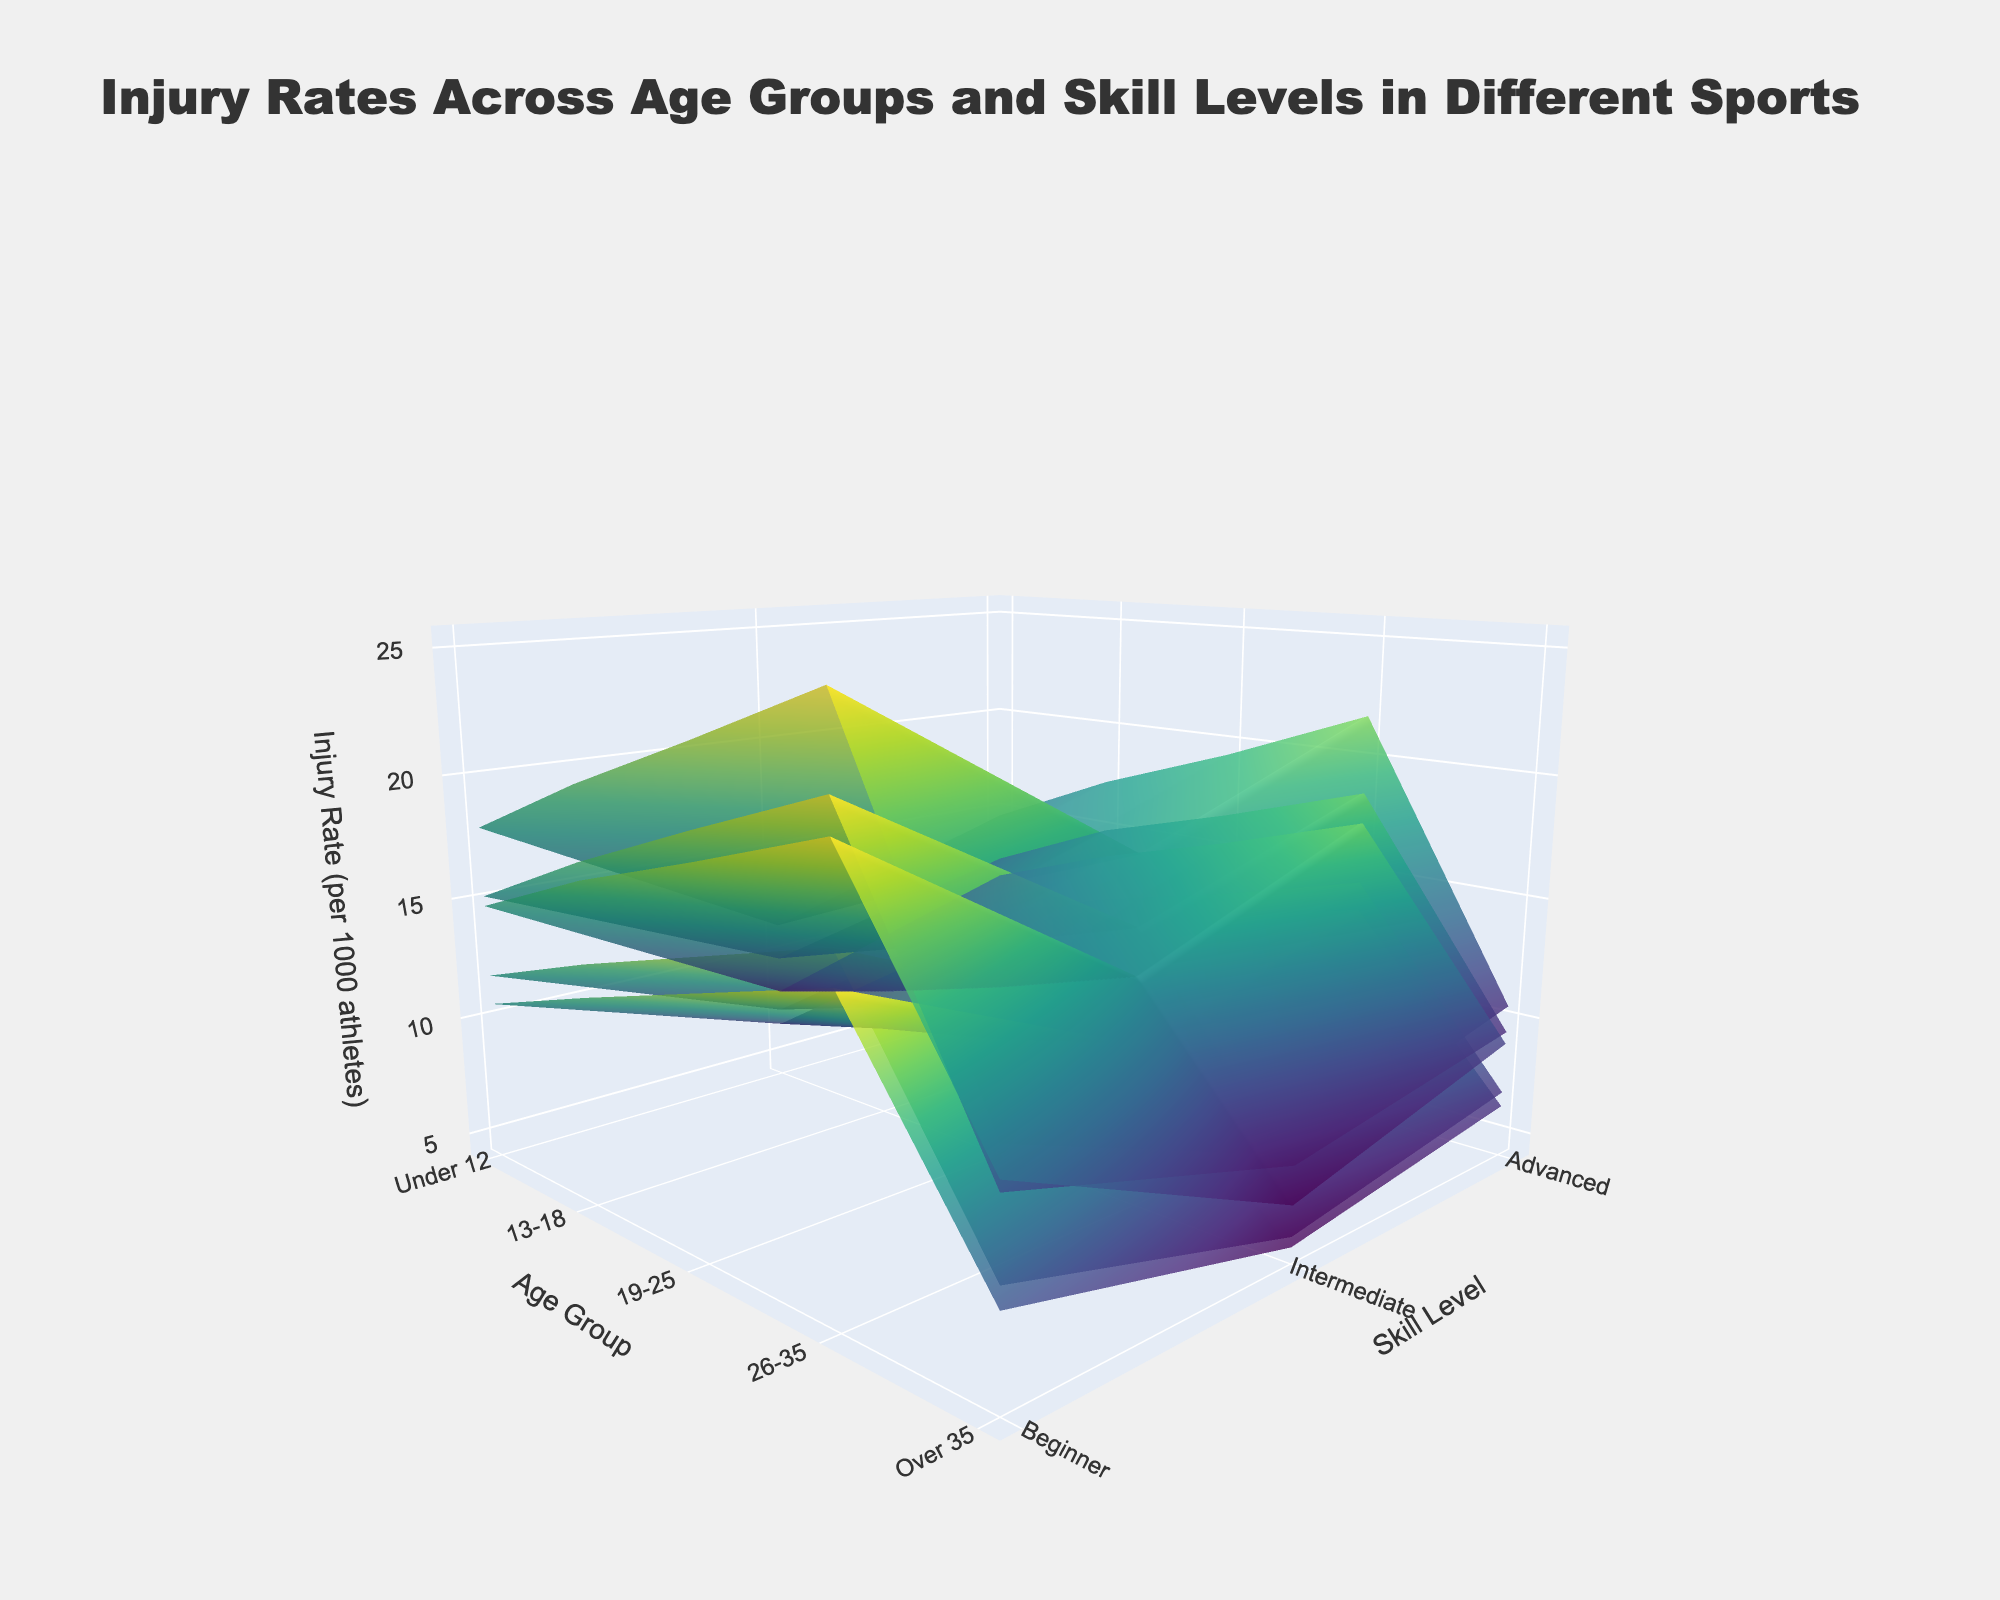What is the title of the figure? The title is prominently displayed at the top center of the figure. It reads "Injury Rates Across Age Groups and Skill Levels in Different Sports".
Answer: Injury Rates Across Age Groups and Skill Levels in Different Sports Which sport shows the highest injury rate for Advanced skill level in the 26-35 age group? To find this, navigate to the point where the x-axis represents the "26-35" age group and the y-axis represents "Advanced" skill level. Among the highest points on this intersection, Ice Hockey has the highest value.
Answer: Ice Hockey What is the difference in injury rates between Football and Gymnastics for the Intermediate skill level in the 13-18 age group? Check the points where the x-axis represents the "13-18" age group and the y-axis denotes the "Intermediate" skill level for both Football and Gymnastics. The difference is the calculation between Football (14.6) and Gymnastics (11.4).
Answer: 3.2 Which age group shows the lowest injury rate for Beginner skill level in Basketball? Scan the surface corresponding to Beginner skill level for Basketball across all age groups. The lowest point appears in the "Under 12" group.
Answer: Under 12 How does the injury rate for Soccer change from Beginner to Advanced skill level in the 19-25 age group? Track the intersection for the 19-25 age group while observing the height difference from the "Beginner" to "Advanced" skill levels. Soccer rates increase as follows: Beginner (7.9), Intermediate (10.2), and Advanced (12.4).
Answer: It increases For the Advanced skill level, which age group has the smallest range of injury rates across all sports? Observe the intersection of the "Advanced" skill level with all age groups, then examine the difference between the highest and lowest points for all sports. "Under 12" has the smallest range when comparing the heights for Football (12.7), Basketball (8.3), Soccer (7.5), Ice Hockey (11.2), and Gymnastics (11.6).
Answer: Under 12 Looking at the Injury Rates for Gymnastics, which skill level in the Over 35 age group has the highest injury rate? Follow the column representing the "Over 35" age group and compare height levels for different skill levels. The "Advanced" skill level shows the highest rate.
Answer: Advanced Does the injury rate for Ice Hockey consistently increase with age in the Intermediate skill level? Check the surface plot for Ice Hockey on the Intermediate skill level across increasing age groups ("Under 12" to "Over 35"). The injury rates rise as follows: Under 12 (9.4), 13-18 (12.3), 19-25 (14.8), 26-35 (16.5), Over 35 (18.4).
Answer: Yes At which age group and skill level is the injury rate for Basketball approximately 10? Look at the points on the Basketball surface plot where the z-axis values are near 10.0. This point is close to "26-35" age group and "Beginner" skill level.
Answer: 26-35, Beginner For the 13-18 age group, how does the injury rate for Soccer compare between Intermediate and Advanced skill levels? Compare the z-axis values for Soccer at the intersection of the x-axis representing "13-18" and y-axis for "Intermediate" and "Advanced". Intermediate is 8.8, and Advanced is 10.6.
Answer: Intermediate is lower 